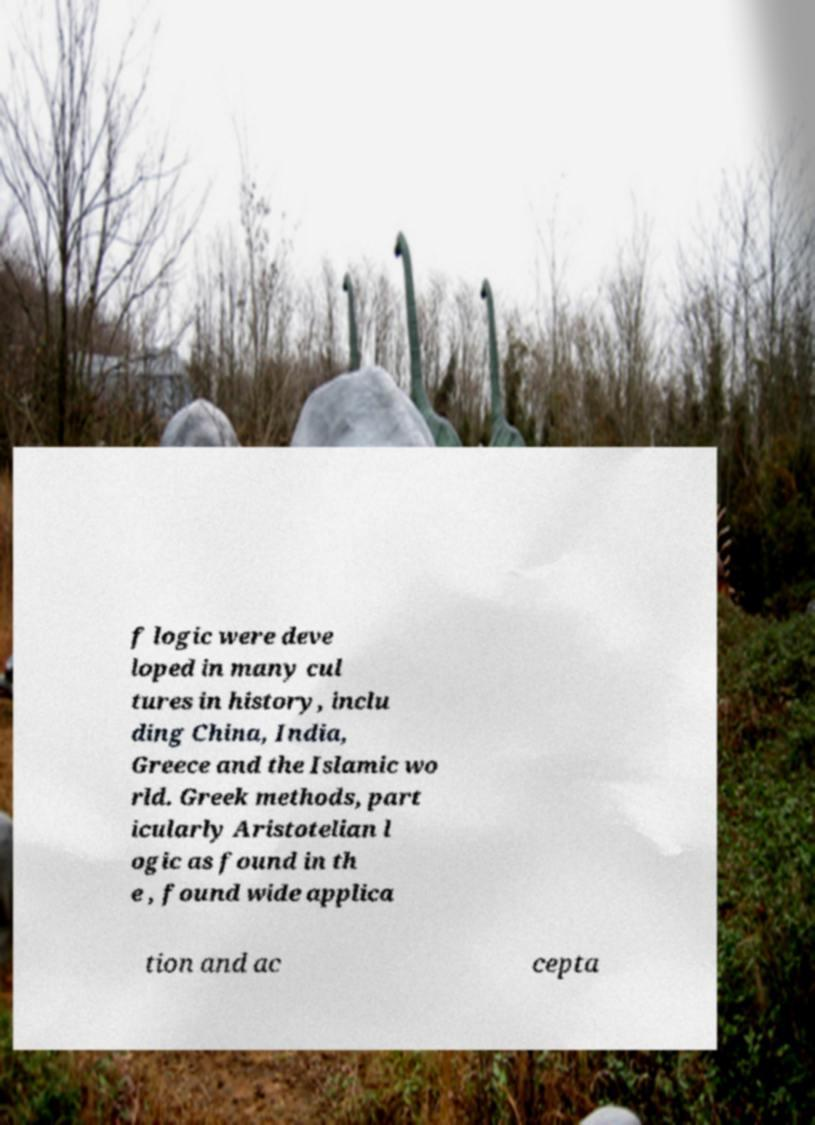Please read and relay the text visible in this image. What does it say? f logic were deve loped in many cul tures in history, inclu ding China, India, Greece and the Islamic wo rld. Greek methods, part icularly Aristotelian l ogic as found in th e , found wide applica tion and ac cepta 